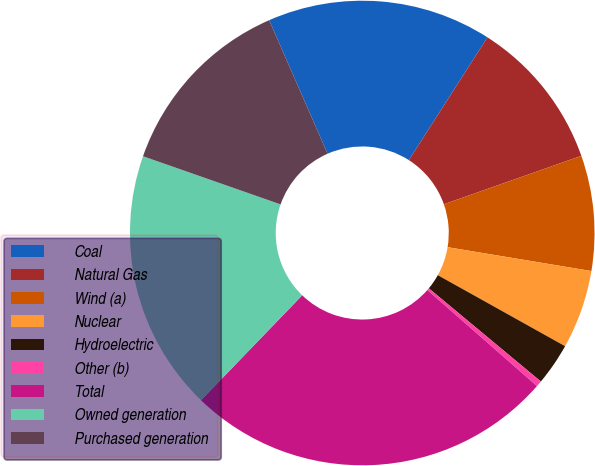Convert chart. <chart><loc_0><loc_0><loc_500><loc_500><pie_chart><fcel>Coal<fcel>Natural Gas<fcel>Wind (a)<fcel>Nuclear<fcel>Hydroelectric<fcel>Other (b)<fcel>Total<fcel>Owned generation<fcel>Purchased generation<nl><fcel>15.62%<fcel>10.55%<fcel>8.01%<fcel>5.48%<fcel>2.94%<fcel>0.41%<fcel>25.76%<fcel>18.15%<fcel>13.08%<nl></chart> 